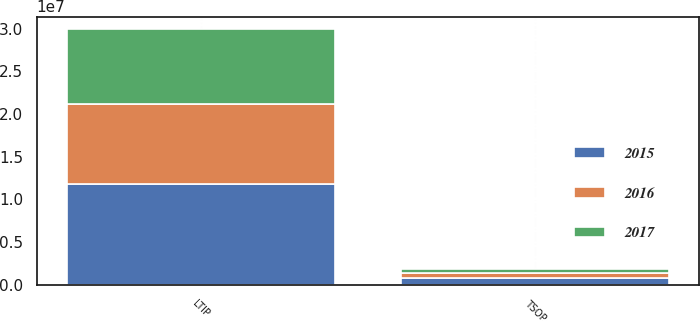Convert chart to OTSL. <chart><loc_0><loc_0><loc_500><loc_500><stacked_bar_chart><ecel><fcel>LTIP<fcel>TSOP<nl><fcel>2017<fcel>8.77477e+06<fcel>410895<nl><fcel>2016<fcel>9.38567e+06<fcel>544217<nl><fcel>2015<fcel>1.17698e+07<fcel>832676<nl></chart> 